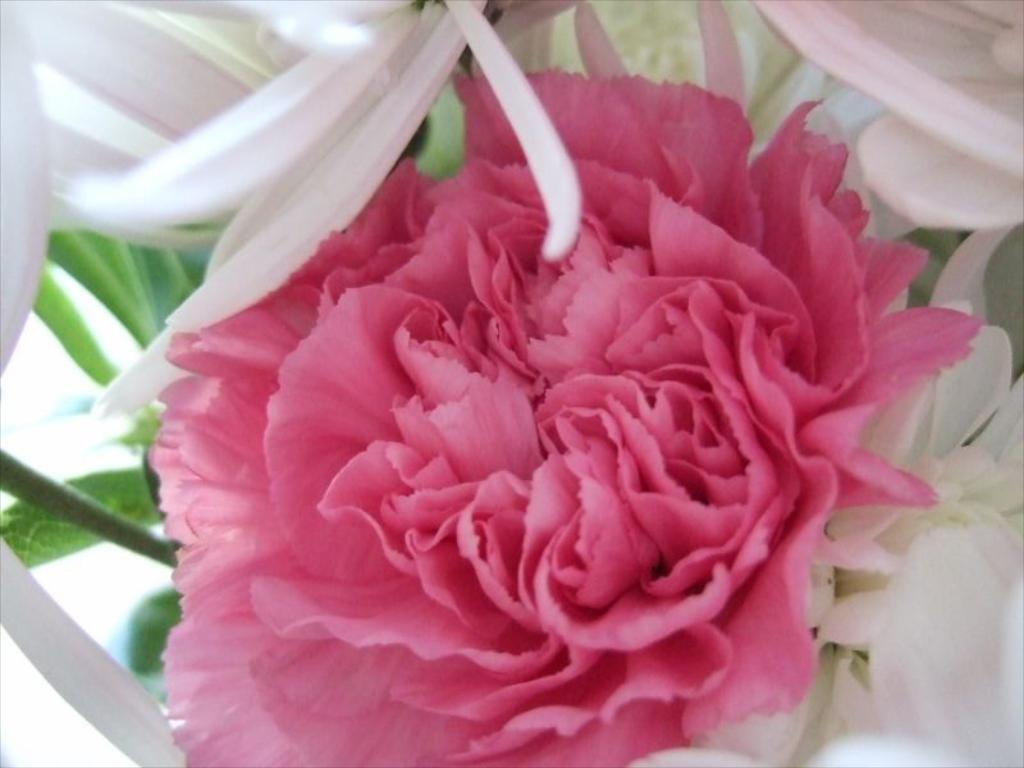What type of plants can be seen in the picture? There are flowers in the picture. What colors are the flowers? The flowers are pink and white in color. What type of yarn is being used to create the flowers in the image? There is no yarn present in the image; the flowers are actual plants. 